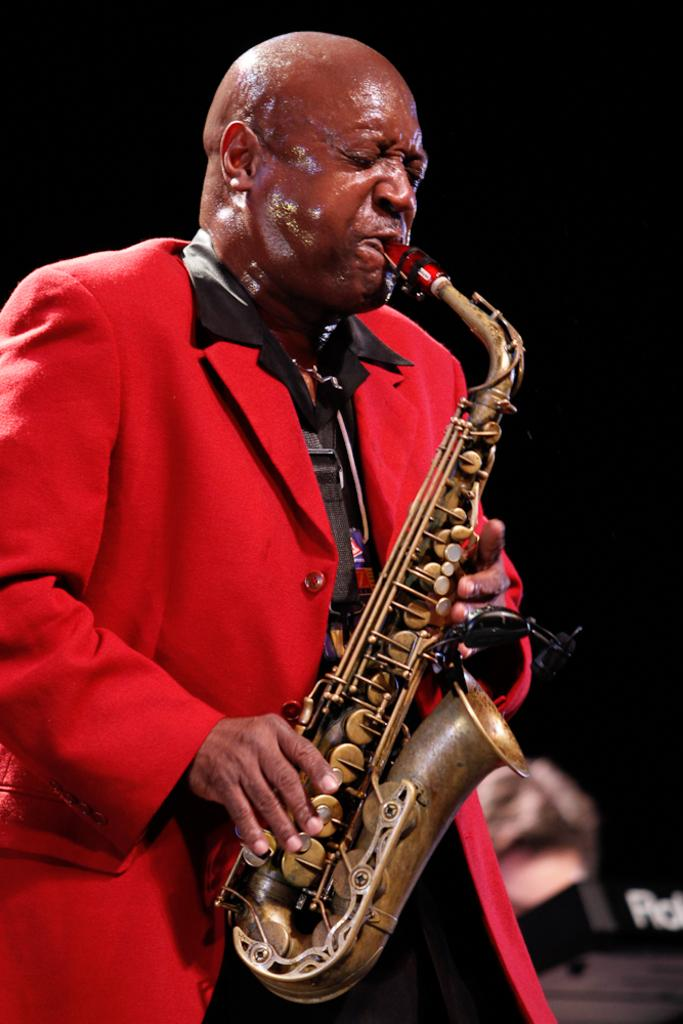What is the main subject of the image? There is a person in the image. What is the person doing in the image? The person is playing a trombone. Can you see any skateboarding tricks being performed in the image? There is no skateboard or any indication of skateboarding tricks in the image. Is the person in the image reading a fictional story while playing the trombone? There is no mention of a book or any reading material in the image, and the person is focused on playing the trombone. 